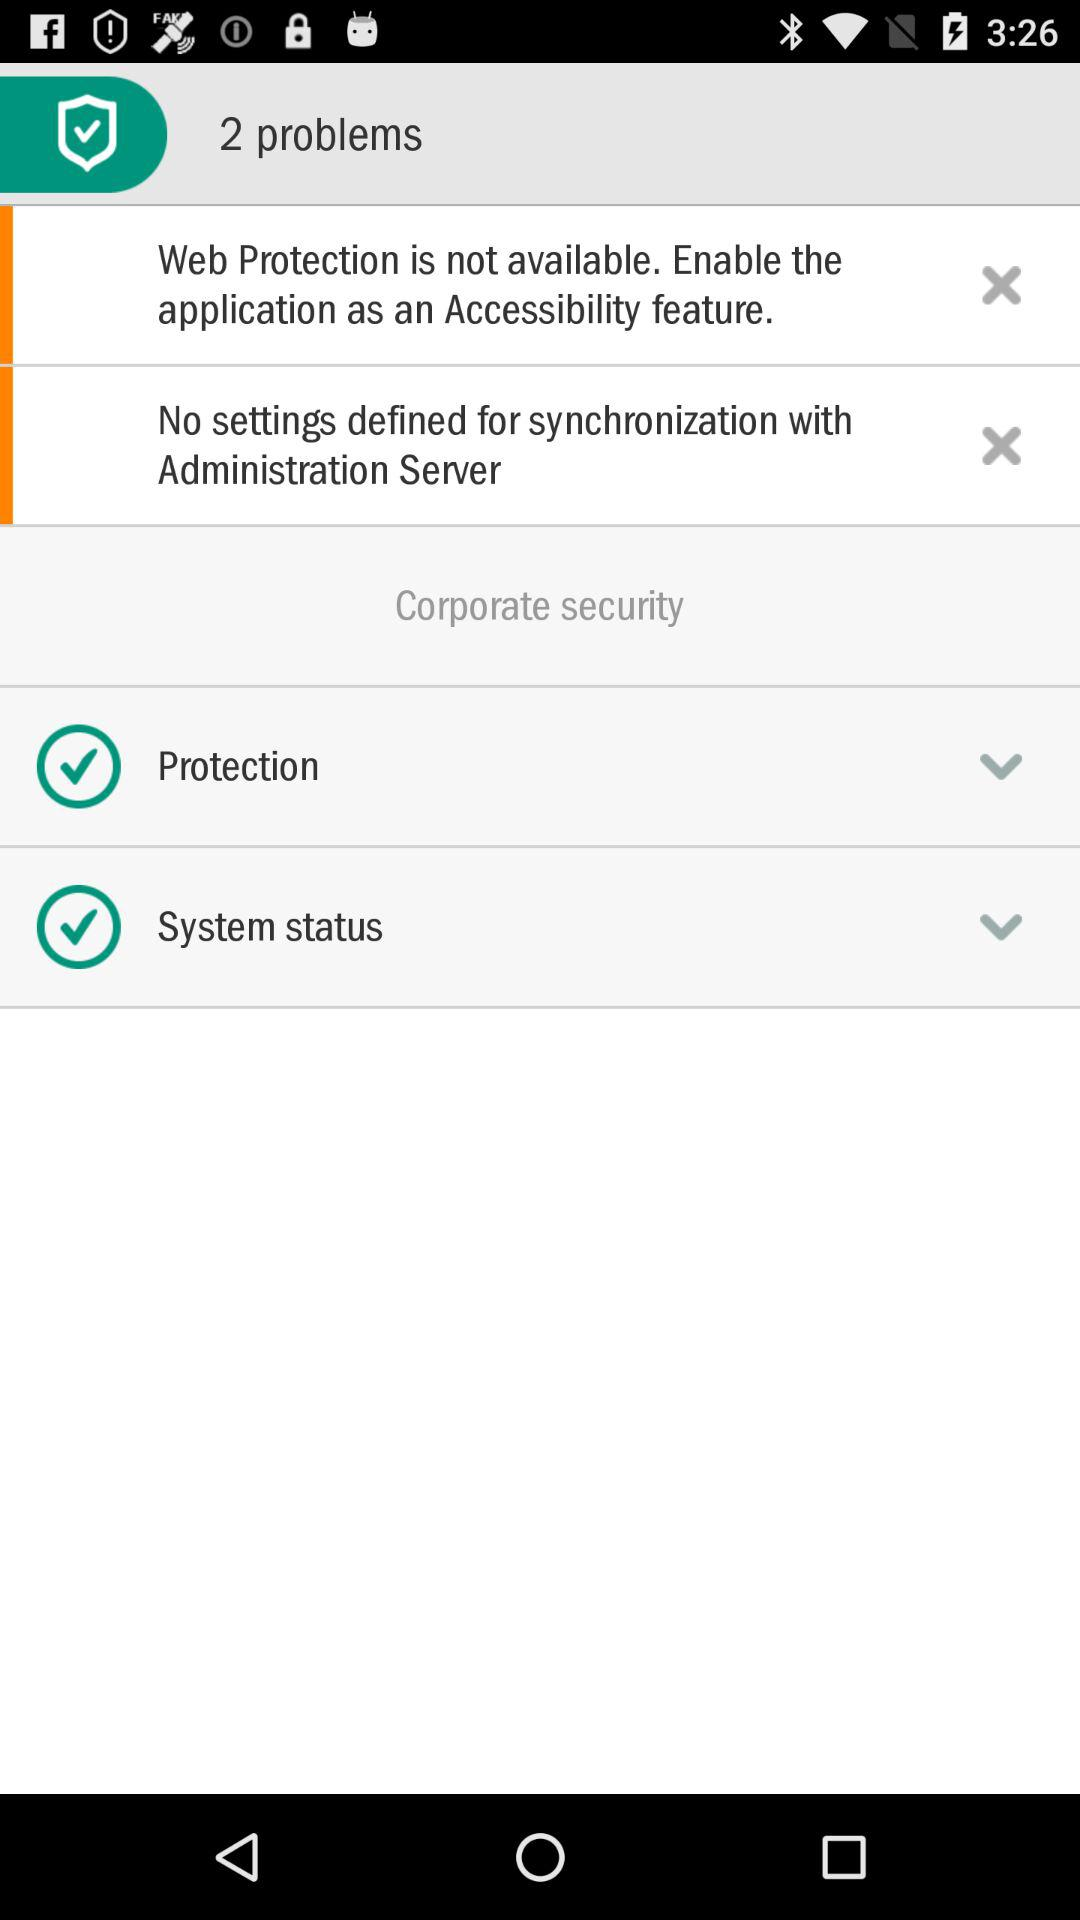How many problems are there?
Answer the question using a single word or phrase. 2 